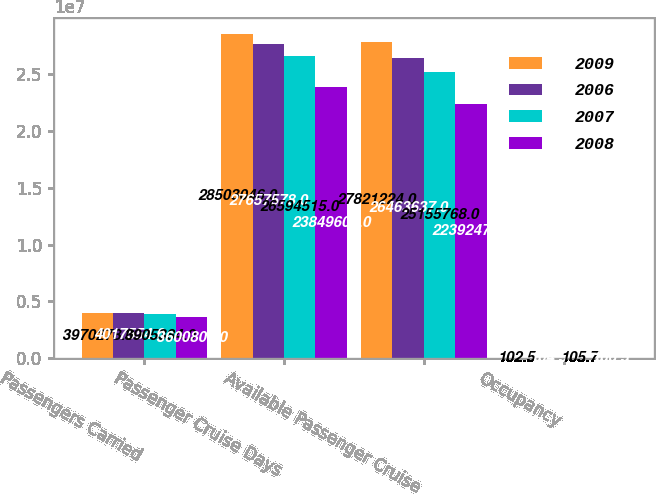Convert chart. <chart><loc_0><loc_0><loc_500><loc_500><stacked_bar_chart><ecel><fcel>Passengers Carried<fcel>Passenger Cruise Days<fcel>Available Passenger Cruise<fcel>Occupancy<nl><fcel>2009<fcel>3.97028e+06<fcel>2.8503e+07<fcel>2.78212e+07<fcel>102.5<nl><fcel>2006<fcel>4.01755e+06<fcel>2.76576e+07<fcel>2.64636e+07<fcel>104.5<nl><fcel>2007<fcel>3.90538e+06<fcel>2.65945e+07<fcel>2.51558e+07<fcel>105.7<nl><fcel>2008<fcel>3.60081e+06<fcel>2.38496e+07<fcel>2.23925e+07<fcel>106.5<nl></chart> 